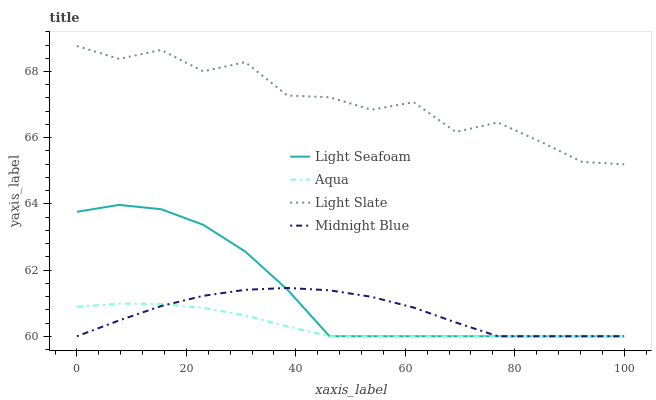Does Aqua have the minimum area under the curve?
Answer yes or no. Yes. Does Light Slate have the maximum area under the curve?
Answer yes or no. Yes. Does Light Seafoam have the minimum area under the curve?
Answer yes or no. No. Does Light Seafoam have the maximum area under the curve?
Answer yes or no. No. Is Aqua the smoothest?
Answer yes or no. Yes. Is Light Slate the roughest?
Answer yes or no. Yes. Is Light Seafoam the smoothest?
Answer yes or no. No. Is Light Seafoam the roughest?
Answer yes or no. No. Does Light Seafoam have the lowest value?
Answer yes or no. Yes. Does Light Slate have the highest value?
Answer yes or no. Yes. Does Light Seafoam have the highest value?
Answer yes or no. No. Is Aqua less than Light Slate?
Answer yes or no. Yes. Is Light Slate greater than Light Seafoam?
Answer yes or no. Yes. Does Light Seafoam intersect Aqua?
Answer yes or no. Yes. Is Light Seafoam less than Aqua?
Answer yes or no. No. Is Light Seafoam greater than Aqua?
Answer yes or no. No. Does Aqua intersect Light Slate?
Answer yes or no. No. 